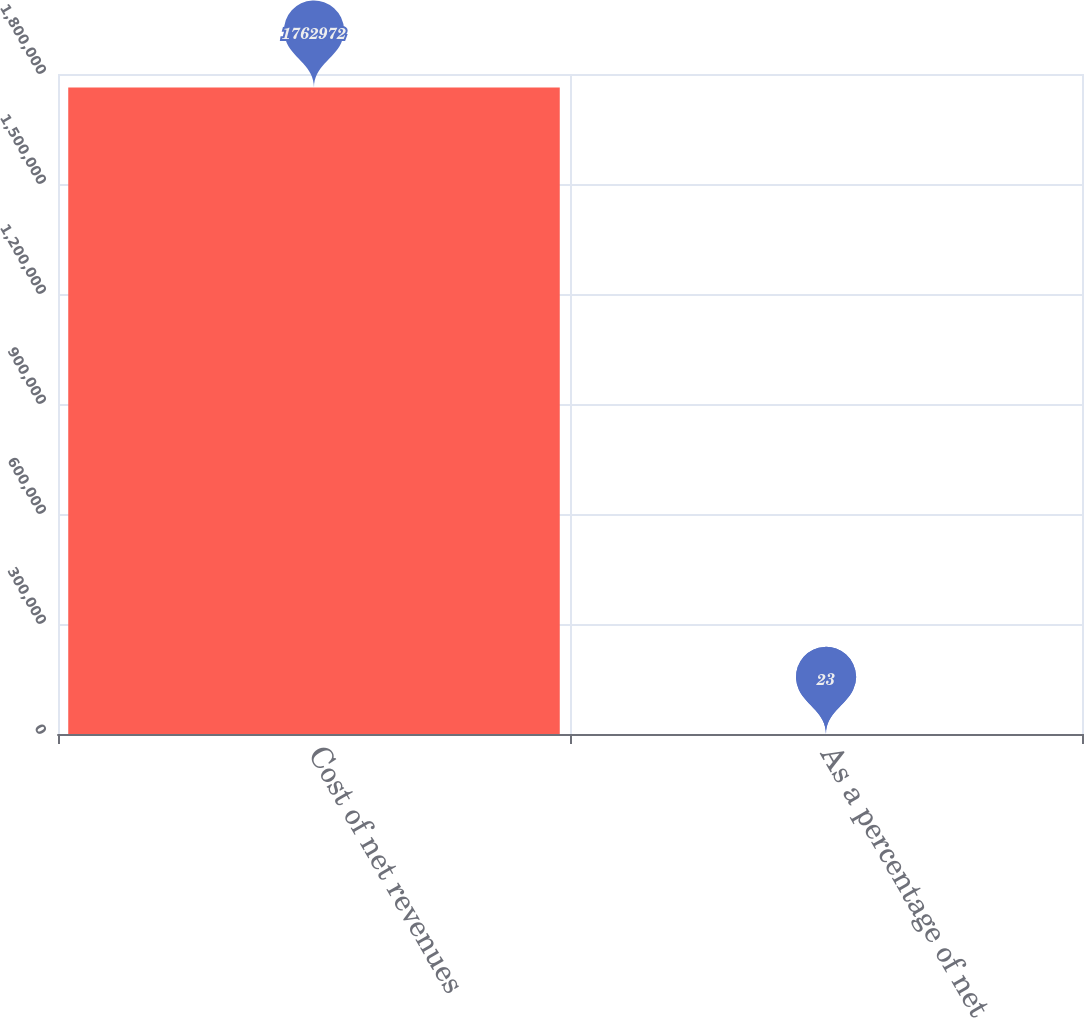<chart> <loc_0><loc_0><loc_500><loc_500><bar_chart><fcel>Cost of net revenues<fcel>As a percentage of net<nl><fcel>1.76297e+06<fcel>23<nl></chart> 